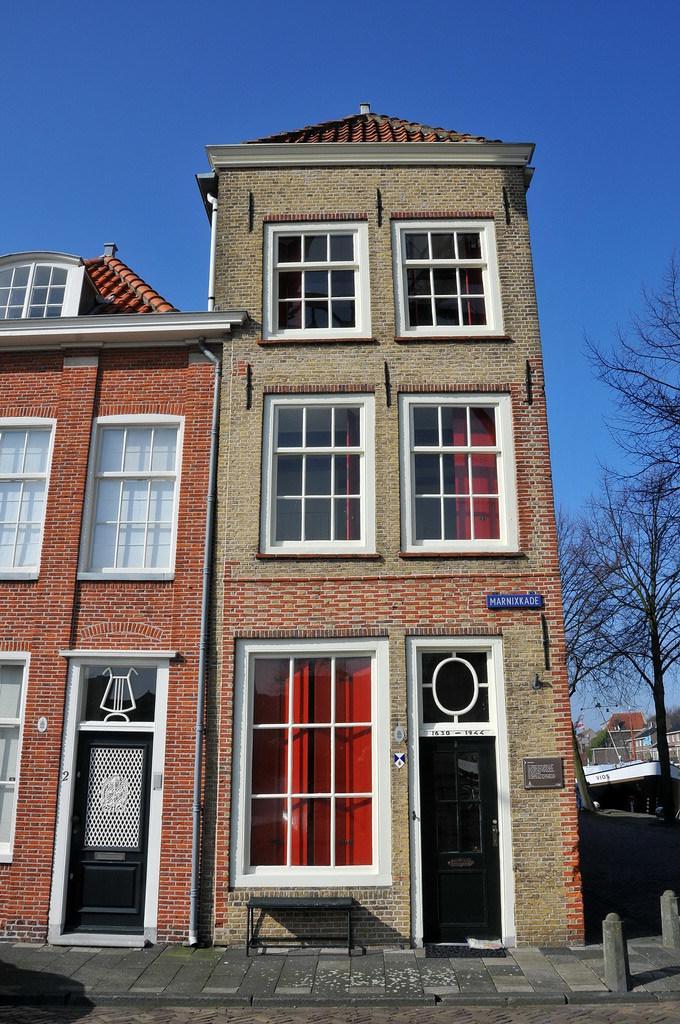Describe this image in one or two sentences. In this image we can see buildings, in front of it glass windows and doors are there. Right side of the image trees are present. The sky is in blue color. In front of the buildings pavement is present. 